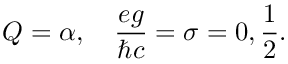<formula> <loc_0><loc_0><loc_500><loc_500>Q = { \alpha } , \quad \frac { e g } { \hbar { c } } = \sigma = 0 , \frac { 1 } { 2 } .</formula> 